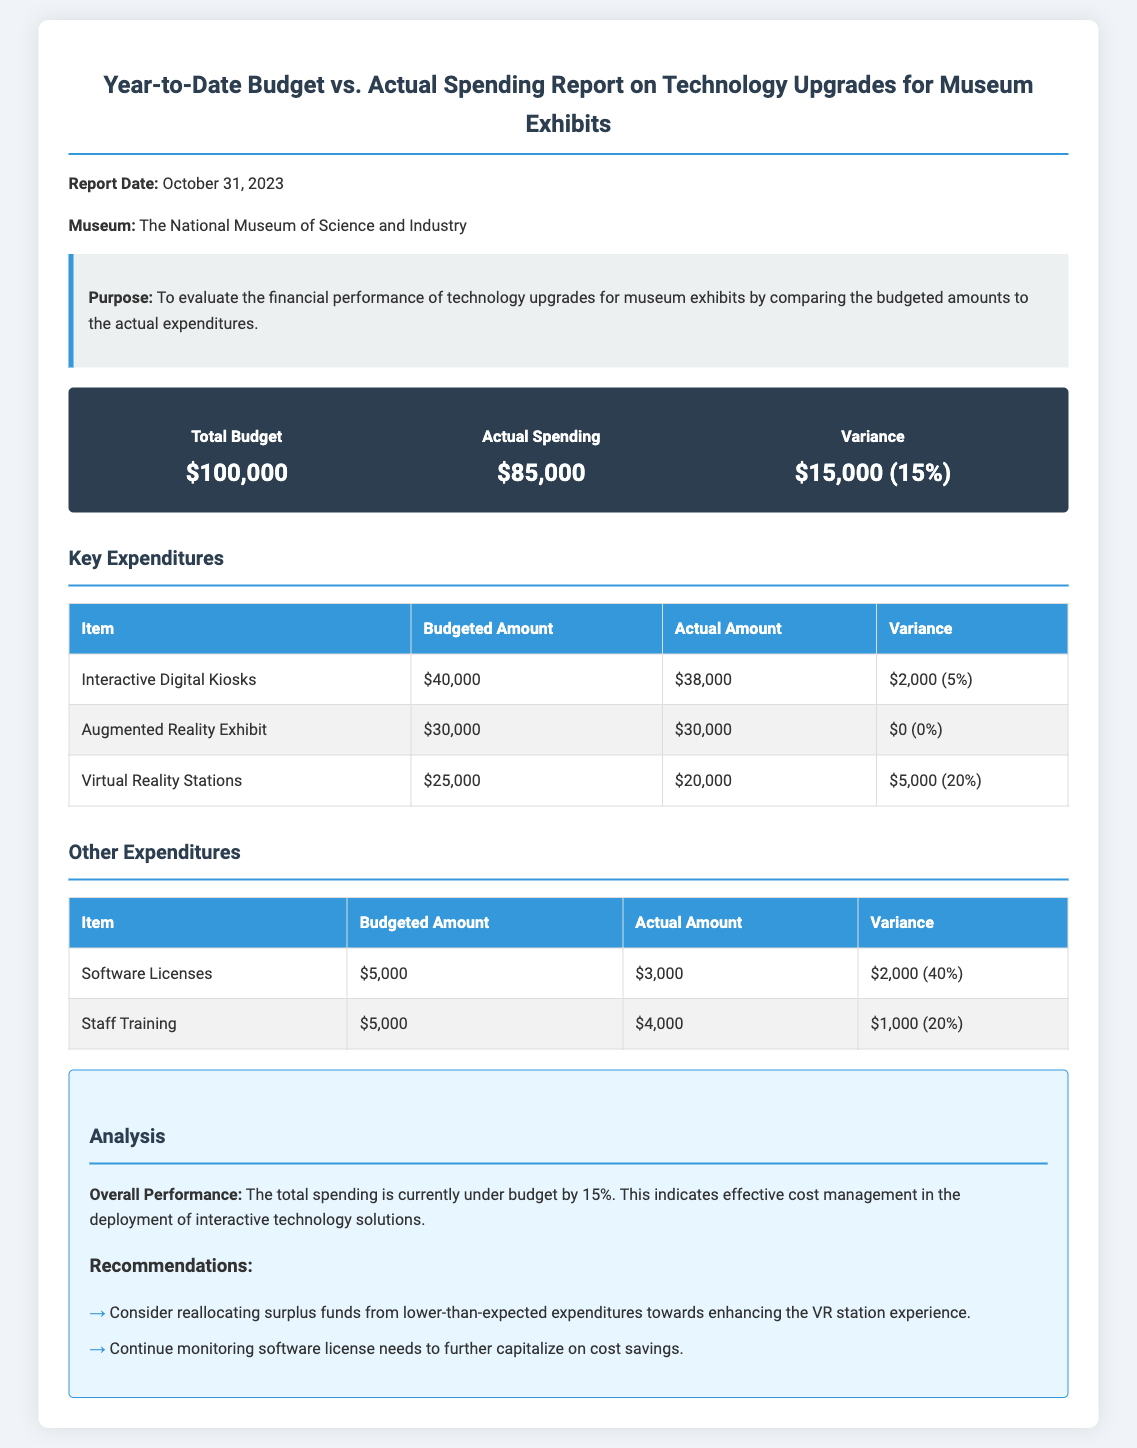What is the total budget? The total budget amount listed in the document is $100,000.
Answer: $100,000 What is the actual spending amount? The document states that actual spending is $85,000.
Answer: $85,000 What is the variance in budget vs. actual spending? The variance between the budget and actual spending is shown as $15,000 (15%).
Answer: $15,000 (15%) How much was spent on Interactive Digital Kiosks? The actual amount spent on Interactive Digital Kiosks is $38,000 as per the table.
Answer: $38,000 What is the budgeted amount for Staff Training? The budgeted amount for Staff Training is $5,000 according to the document.
Answer: $5,000 What is the variance for Virtual Reality Stations? The variance for Virtual Reality Stations is $5,000 (20%).
Answer: $5,000 (20%) What is the museum's name mentioned in the report? The report identifies the museum as The National Museum of Science and Industry.
Answer: The National Museum of Science and Industry What is the overall performance regarding budget spending? The overall performance indicates that total spending is under budget by 15%.
Answer: under budget by 15% What recommendation is given for enhancing the VR station experience? One recommendation is to consider reallocating surplus funds from lower-than-expected expenditures.
Answer: reallocating surplus funds 